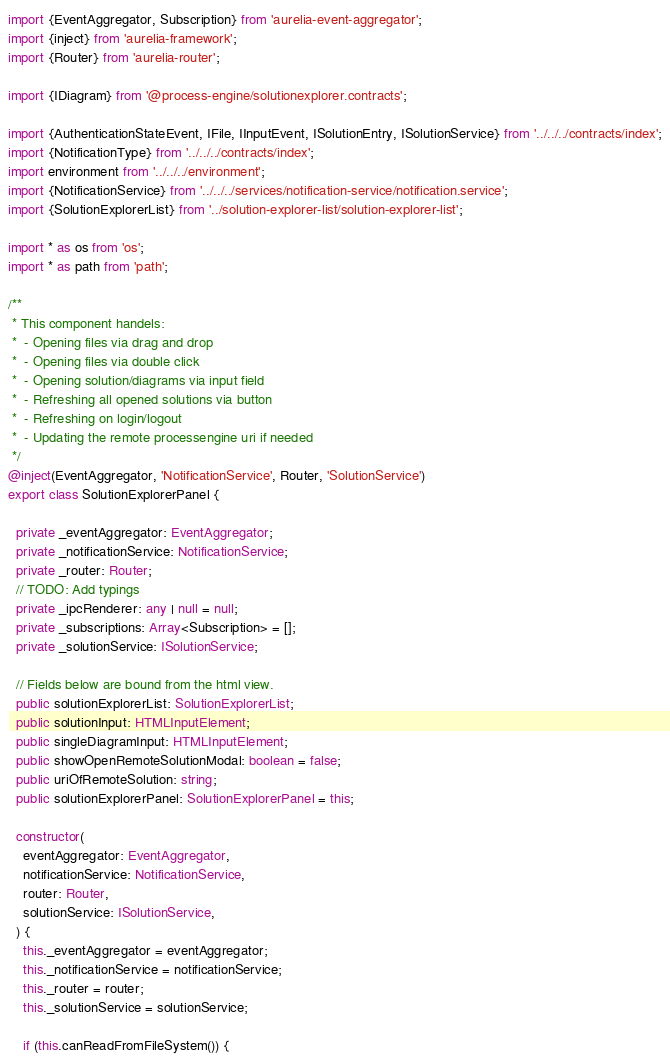<code> <loc_0><loc_0><loc_500><loc_500><_TypeScript_>import {EventAggregator, Subscription} from 'aurelia-event-aggregator';
import {inject} from 'aurelia-framework';
import {Router} from 'aurelia-router';

import {IDiagram} from '@process-engine/solutionexplorer.contracts';

import {AuthenticationStateEvent, IFile, IInputEvent, ISolutionEntry, ISolutionService} from '../../../contracts/index';
import {NotificationType} from '../../../contracts/index';
import environment from '../../../environment';
import {NotificationService} from '../../../services/notification-service/notification.service';
import {SolutionExplorerList} from '../solution-explorer-list/solution-explorer-list';

import * as os from 'os';
import * as path from 'path';

/**
 * This component handels:
 *  - Opening files via drag and drop
 *  - Opening files via double click
 *  - Opening solution/diagrams via input field
 *  - Refreshing all opened solutions via button
 *  - Refreshing on login/logout
 *  - Updating the remote processengine uri if needed
 */
@inject(EventAggregator, 'NotificationService', Router, 'SolutionService')
export class SolutionExplorerPanel {

  private _eventAggregator: EventAggregator;
  private _notificationService: NotificationService;
  private _router: Router;
  // TODO: Add typings
  private _ipcRenderer: any | null = null;
  private _subscriptions: Array<Subscription> = [];
  private _solutionService: ISolutionService;

  // Fields below are bound from the html view.
  public solutionExplorerList: SolutionExplorerList;
  public solutionInput: HTMLInputElement;
  public singleDiagramInput: HTMLInputElement;
  public showOpenRemoteSolutionModal: boolean = false;
  public uriOfRemoteSolution: string;
  public solutionExplorerPanel: SolutionExplorerPanel = this;

  constructor(
    eventAggregator: EventAggregator,
    notificationService: NotificationService,
    router: Router,
    solutionService: ISolutionService,
  ) {
    this._eventAggregator = eventAggregator;
    this._notificationService = notificationService;
    this._router = router;
    this._solutionService = solutionService;

    if (this.canReadFromFileSystem()) {</code> 